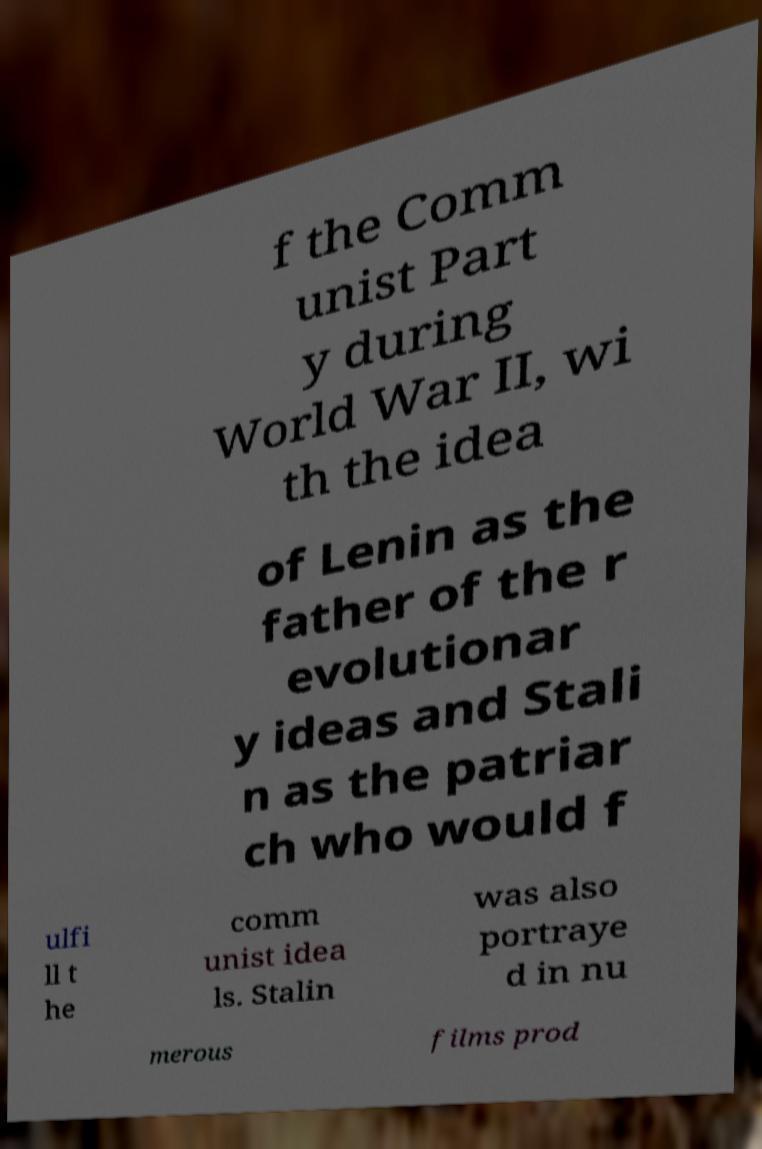Can you read and provide the text displayed in the image?This photo seems to have some interesting text. Can you extract and type it out for me? f the Comm unist Part y during World War II, wi th the idea of Lenin as the father of the r evolutionar y ideas and Stali n as the patriar ch who would f ulfi ll t he comm unist idea ls. Stalin was also portraye d in nu merous films prod 